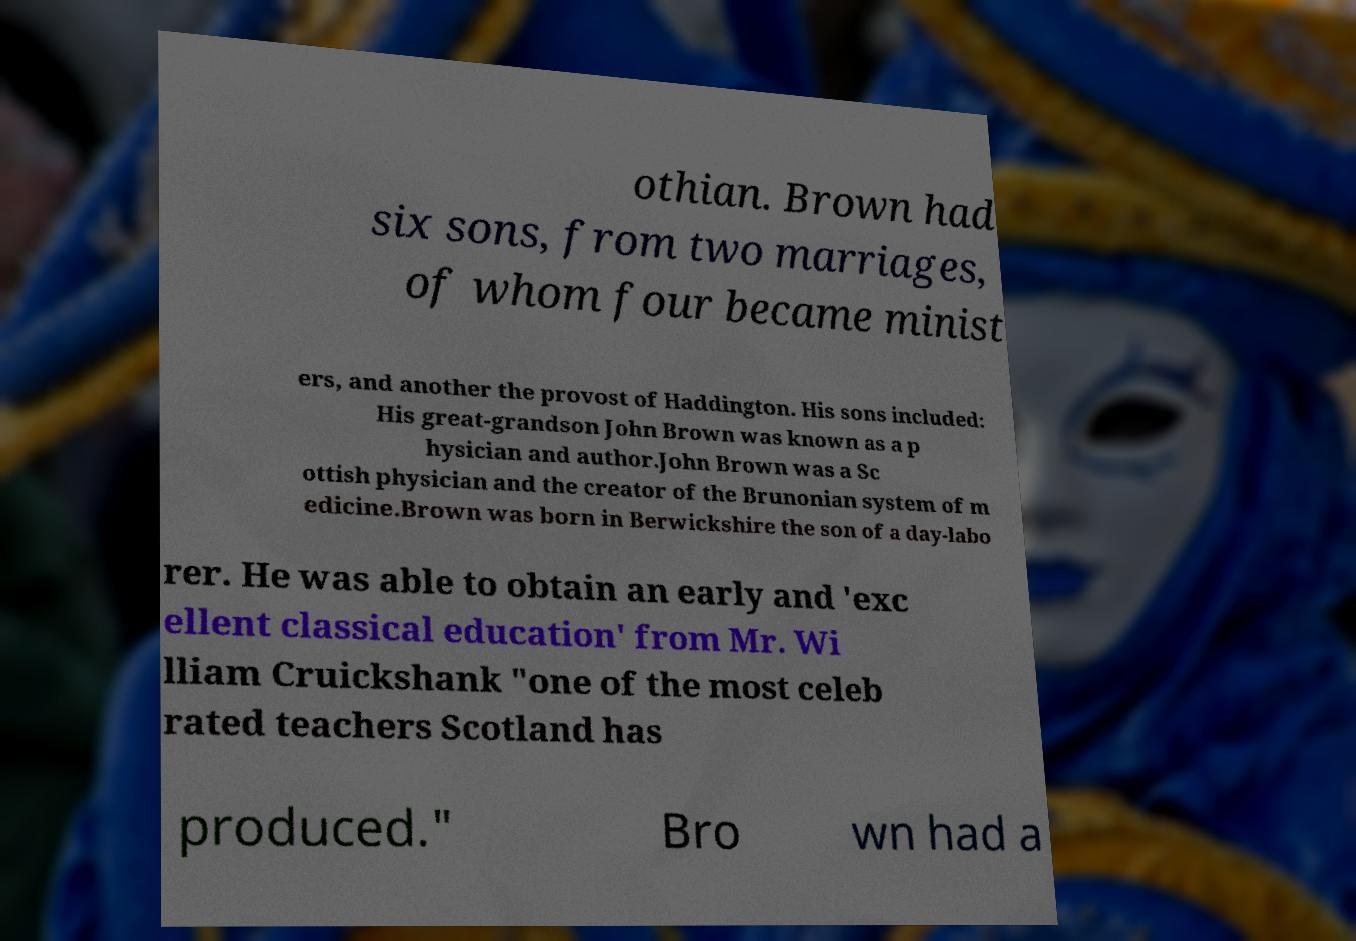Can you read and provide the text displayed in the image?This photo seems to have some interesting text. Can you extract and type it out for me? othian. Brown had six sons, from two marriages, of whom four became minist ers, and another the provost of Haddington. His sons included: His great-grandson John Brown was known as a p hysician and author.John Brown was a Sc ottish physician and the creator of the Brunonian system of m edicine.Brown was born in Berwickshire the son of a day-labo rer. He was able to obtain an early and 'exc ellent classical education' from Mr. Wi lliam Cruickshank "one of the most celeb rated teachers Scotland has produced." Bro wn had a 